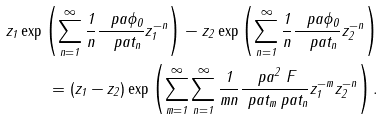Convert formula to latex. <formula><loc_0><loc_0><loc_500><loc_500>z _ { 1 } \exp \left ( \sum _ { n = 1 } ^ { \infty } \frac { 1 } { n } \frac { \ p a \phi _ { 0 } } { \ p a t _ { n } } z _ { 1 } ^ { - n } \right ) - z _ { 2 } \exp \left ( \sum _ { n = 1 } ^ { \infty } \frac { 1 } { n } \frac { \ p a \phi _ { 0 } } { \ p a t _ { n } } z _ { 2 } ^ { - n } \right ) \\ = ( z _ { 1 } - z _ { 2 } ) \exp \left ( \sum _ { m = 1 } ^ { \infty } \sum _ { n = 1 } ^ { \infty } \frac { 1 } { m n } \frac { \ p a ^ { 2 } \ F } { \ p a t _ { m } \ p a t _ { n } } z _ { 1 } ^ { - m } z _ { 2 } ^ { - n } \right ) .</formula> 